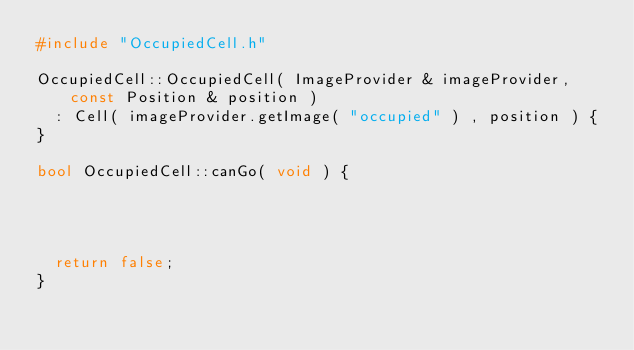Convert code to text. <code><loc_0><loc_0><loc_500><loc_500><_C++_>#include "OccupiedCell.h"

OccupiedCell::OccupiedCell( ImageProvider & imageProvider, const Position & position )
	: Cell( imageProvider.getImage( "occupied" ) , position ) {
}

bool OccupiedCell::canGo( void ) {




	return false;
}

</code> 